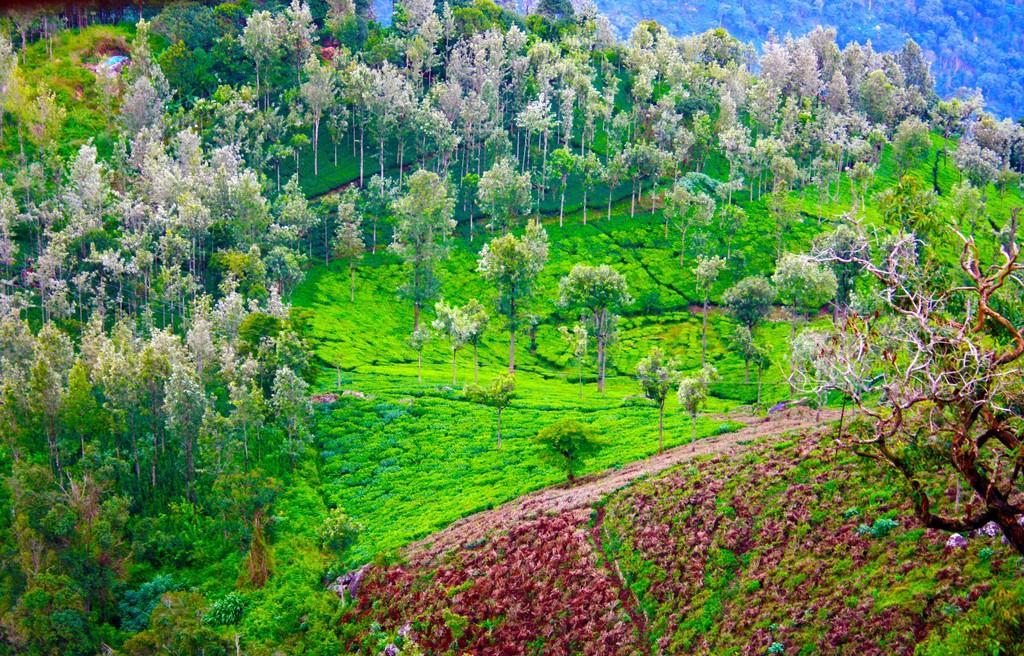Can you describe this image briefly? In this image, we can see trees and at the bottom, there are plants and there is ground. 